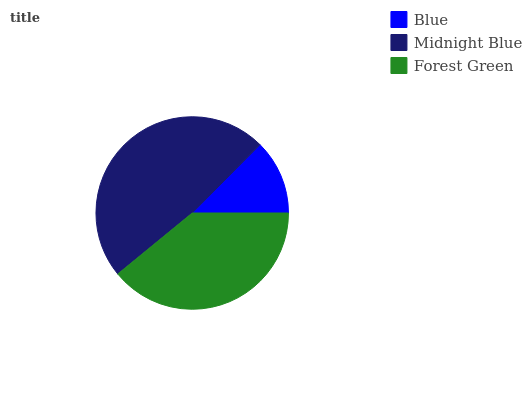Is Blue the minimum?
Answer yes or no. Yes. Is Midnight Blue the maximum?
Answer yes or no. Yes. Is Forest Green the minimum?
Answer yes or no. No. Is Forest Green the maximum?
Answer yes or no. No. Is Midnight Blue greater than Forest Green?
Answer yes or no. Yes. Is Forest Green less than Midnight Blue?
Answer yes or no. Yes. Is Forest Green greater than Midnight Blue?
Answer yes or no. No. Is Midnight Blue less than Forest Green?
Answer yes or no. No. Is Forest Green the high median?
Answer yes or no. Yes. Is Forest Green the low median?
Answer yes or no. Yes. Is Blue the high median?
Answer yes or no. No. Is Blue the low median?
Answer yes or no. No. 